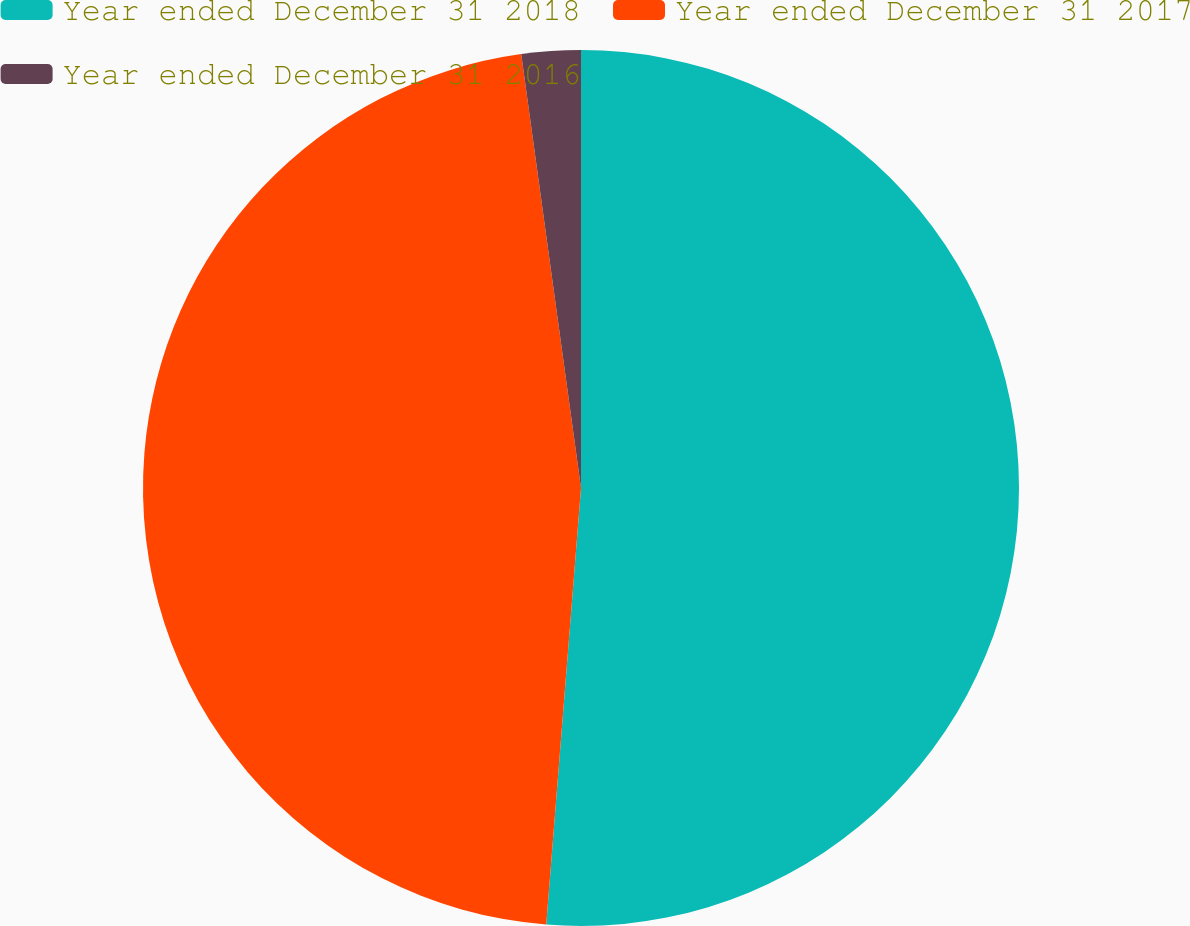Convert chart. <chart><loc_0><loc_0><loc_500><loc_500><pie_chart><fcel>Year ended December 31 2018<fcel>Year ended December 31 2017<fcel>Year ended December 31 2016<nl><fcel>51.27%<fcel>46.56%<fcel>2.18%<nl></chart> 